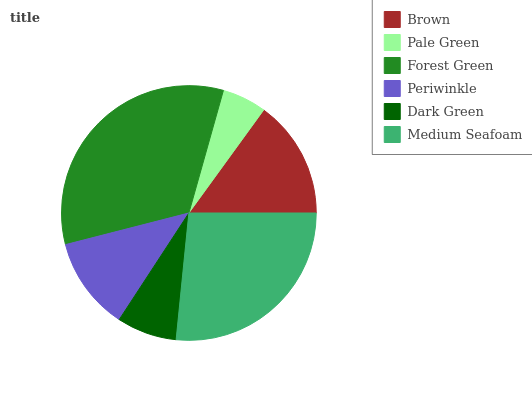Is Pale Green the minimum?
Answer yes or no. Yes. Is Forest Green the maximum?
Answer yes or no. Yes. Is Forest Green the minimum?
Answer yes or no. No. Is Pale Green the maximum?
Answer yes or no. No. Is Forest Green greater than Pale Green?
Answer yes or no. Yes. Is Pale Green less than Forest Green?
Answer yes or no. Yes. Is Pale Green greater than Forest Green?
Answer yes or no. No. Is Forest Green less than Pale Green?
Answer yes or no. No. Is Brown the high median?
Answer yes or no. Yes. Is Periwinkle the low median?
Answer yes or no. Yes. Is Pale Green the high median?
Answer yes or no. No. Is Medium Seafoam the low median?
Answer yes or no. No. 